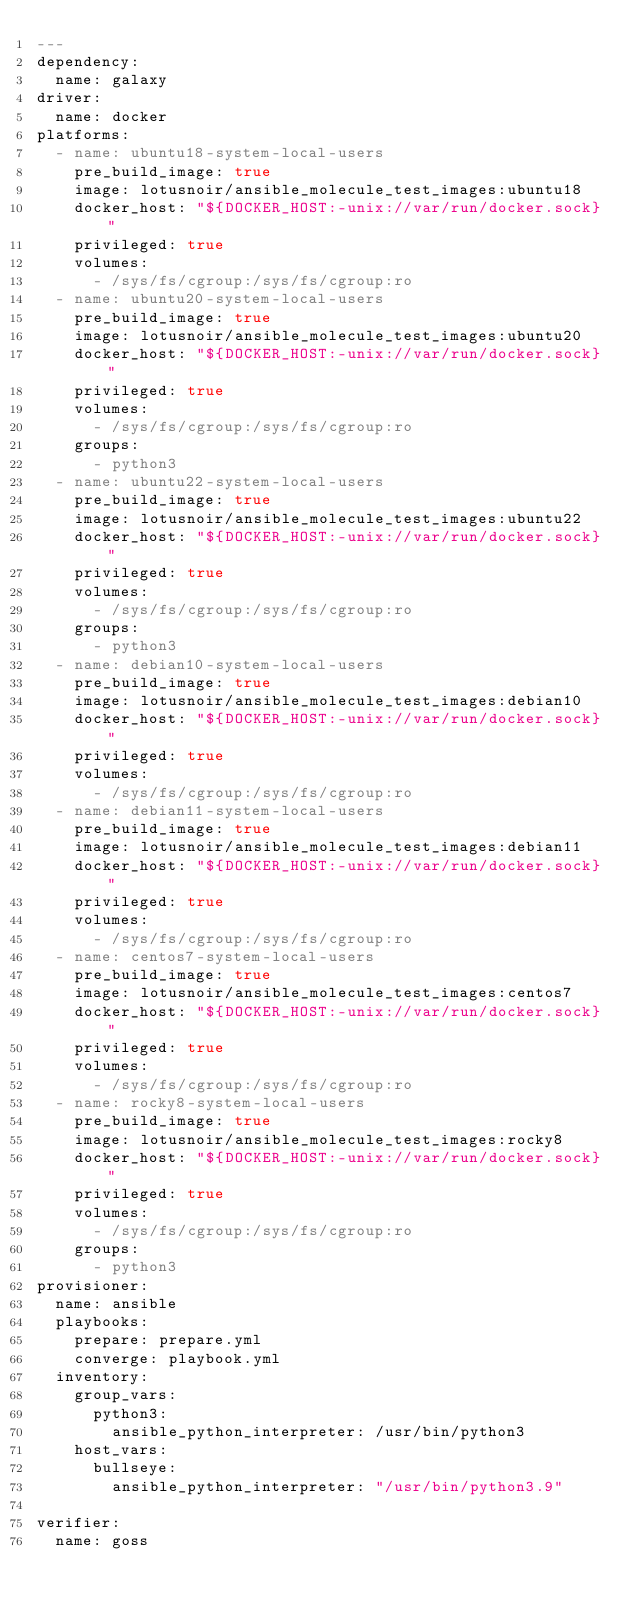Convert code to text. <code><loc_0><loc_0><loc_500><loc_500><_YAML_>---
dependency:
  name: galaxy
driver:
  name: docker
platforms:
  - name: ubuntu18-system-local-users
    pre_build_image: true
    image: lotusnoir/ansible_molecule_test_images:ubuntu18
    docker_host: "${DOCKER_HOST:-unix://var/run/docker.sock}"
    privileged: true
    volumes:
      - /sys/fs/cgroup:/sys/fs/cgroup:ro
  - name: ubuntu20-system-local-users
    pre_build_image: true
    image: lotusnoir/ansible_molecule_test_images:ubuntu20
    docker_host: "${DOCKER_HOST:-unix://var/run/docker.sock}"
    privileged: true
    volumes:
      - /sys/fs/cgroup:/sys/fs/cgroup:ro
    groups:
      - python3
  - name: ubuntu22-system-local-users
    pre_build_image: true
    image: lotusnoir/ansible_molecule_test_images:ubuntu22
    docker_host: "${DOCKER_HOST:-unix://var/run/docker.sock}"
    privileged: true
    volumes:
      - /sys/fs/cgroup:/sys/fs/cgroup:ro
    groups:
      - python3
  - name: debian10-system-local-users
    pre_build_image: true
    image: lotusnoir/ansible_molecule_test_images:debian10
    docker_host: "${DOCKER_HOST:-unix://var/run/docker.sock}"
    privileged: true
    volumes:
      - /sys/fs/cgroup:/sys/fs/cgroup:ro
  - name: debian11-system-local-users
    pre_build_image: true
    image: lotusnoir/ansible_molecule_test_images:debian11
    docker_host: "${DOCKER_HOST:-unix://var/run/docker.sock}"
    privileged: true
    volumes:
      - /sys/fs/cgroup:/sys/fs/cgroup:ro
  - name: centos7-system-local-users
    pre_build_image: true
    image: lotusnoir/ansible_molecule_test_images:centos7
    docker_host: "${DOCKER_HOST:-unix://var/run/docker.sock}"
    privileged: true
    volumes:
      - /sys/fs/cgroup:/sys/fs/cgroup:ro
  - name: rocky8-system-local-users
    pre_build_image: true
    image: lotusnoir/ansible_molecule_test_images:rocky8
    docker_host: "${DOCKER_HOST:-unix://var/run/docker.sock}"
    privileged: true
    volumes:
      - /sys/fs/cgroup:/sys/fs/cgroup:ro
    groups:
      - python3
provisioner:
  name: ansible
  playbooks:
    prepare: prepare.yml
    converge: playbook.yml
  inventory:
    group_vars:
      python3:
        ansible_python_interpreter: /usr/bin/python3
    host_vars:
      bullseye:
        ansible_python_interpreter: "/usr/bin/python3.9"

verifier:
  name: goss
</code> 